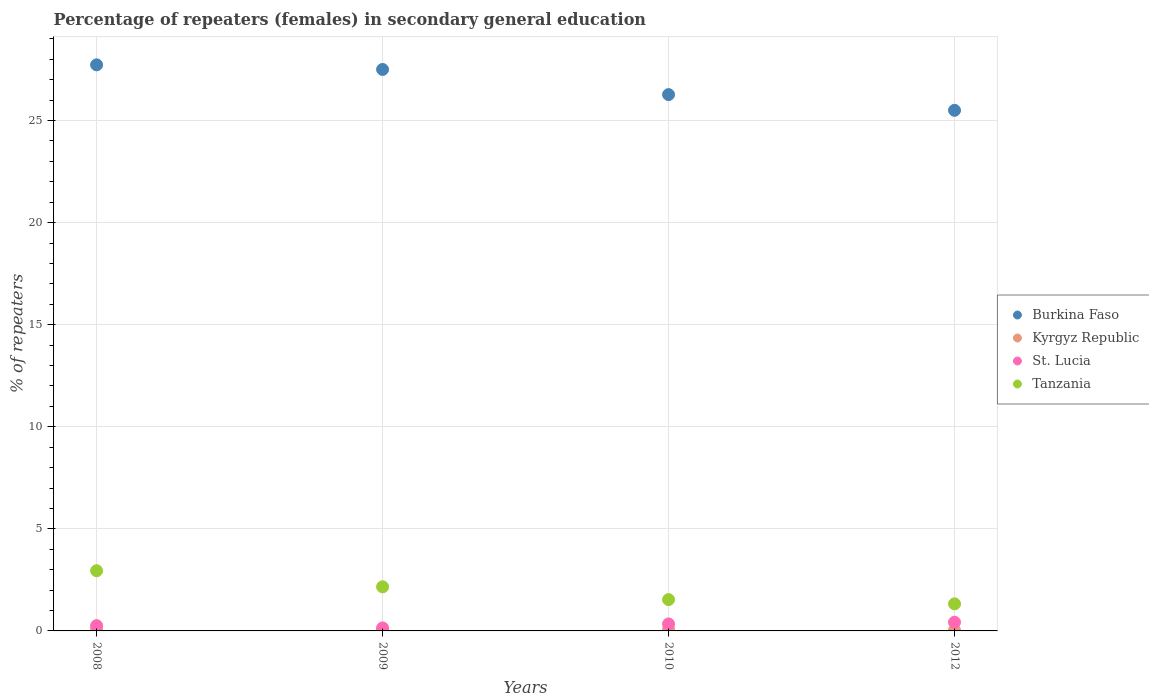Is the number of dotlines equal to the number of legend labels?
Offer a very short reply. Yes. What is the percentage of female repeaters in St. Lucia in 2012?
Provide a succinct answer. 0.43. Across all years, what is the maximum percentage of female repeaters in Tanzania?
Offer a very short reply. 2.95. Across all years, what is the minimum percentage of female repeaters in Burkina Faso?
Your answer should be very brief. 25.5. In which year was the percentage of female repeaters in Tanzania minimum?
Make the answer very short. 2012. What is the total percentage of female repeaters in Burkina Faso in the graph?
Your answer should be very brief. 107.01. What is the difference between the percentage of female repeaters in Tanzania in 2009 and that in 2010?
Ensure brevity in your answer.  0.63. What is the difference between the percentage of female repeaters in Kyrgyz Republic in 2010 and the percentage of female repeaters in Tanzania in 2012?
Offer a terse response. -1.25. What is the average percentage of female repeaters in Tanzania per year?
Make the answer very short. 1.99. In the year 2008, what is the difference between the percentage of female repeaters in Burkina Faso and percentage of female repeaters in Tanzania?
Provide a short and direct response. 24.78. In how many years, is the percentage of female repeaters in Kyrgyz Republic greater than 12 %?
Your answer should be very brief. 0. What is the ratio of the percentage of female repeaters in Kyrgyz Republic in 2009 to that in 2012?
Ensure brevity in your answer.  1.7. Is the difference between the percentage of female repeaters in Burkina Faso in 2009 and 2010 greater than the difference between the percentage of female repeaters in Tanzania in 2009 and 2010?
Your answer should be very brief. Yes. What is the difference between the highest and the second highest percentage of female repeaters in Kyrgyz Republic?
Make the answer very short. 0.01. What is the difference between the highest and the lowest percentage of female repeaters in Burkina Faso?
Keep it short and to the point. 2.23. In how many years, is the percentage of female repeaters in Tanzania greater than the average percentage of female repeaters in Tanzania taken over all years?
Your answer should be compact. 2. Is the sum of the percentage of female repeaters in Tanzania in 2009 and 2010 greater than the maximum percentage of female repeaters in Burkina Faso across all years?
Offer a very short reply. No. Is it the case that in every year, the sum of the percentage of female repeaters in Burkina Faso and percentage of female repeaters in Kyrgyz Republic  is greater than the percentage of female repeaters in St. Lucia?
Your response must be concise. Yes. Does the percentage of female repeaters in Burkina Faso monotonically increase over the years?
Make the answer very short. No. Is the percentage of female repeaters in Burkina Faso strictly less than the percentage of female repeaters in Kyrgyz Republic over the years?
Keep it short and to the point. No. How many years are there in the graph?
Offer a very short reply. 4. Does the graph contain any zero values?
Offer a very short reply. No. Does the graph contain grids?
Your answer should be compact. Yes. Where does the legend appear in the graph?
Give a very brief answer. Center right. What is the title of the graph?
Your answer should be compact. Percentage of repeaters (females) in secondary general education. What is the label or title of the Y-axis?
Your answer should be very brief. % of repeaters. What is the % of repeaters in Burkina Faso in 2008?
Your answer should be very brief. 27.73. What is the % of repeaters of Kyrgyz Republic in 2008?
Provide a short and direct response. 0.08. What is the % of repeaters in St. Lucia in 2008?
Offer a very short reply. 0.26. What is the % of repeaters in Tanzania in 2008?
Your answer should be compact. 2.95. What is the % of repeaters of Burkina Faso in 2009?
Ensure brevity in your answer.  27.5. What is the % of repeaters of Kyrgyz Republic in 2009?
Your answer should be very brief. 0.06. What is the % of repeaters in St. Lucia in 2009?
Your response must be concise. 0.15. What is the % of repeaters of Tanzania in 2009?
Give a very brief answer. 2.16. What is the % of repeaters in Burkina Faso in 2010?
Ensure brevity in your answer.  26.27. What is the % of repeaters in Kyrgyz Republic in 2010?
Make the answer very short. 0.08. What is the % of repeaters of St. Lucia in 2010?
Keep it short and to the point. 0.34. What is the % of repeaters in Tanzania in 2010?
Give a very brief answer. 1.53. What is the % of repeaters of Burkina Faso in 2012?
Offer a very short reply. 25.5. What is the % of repeaters of Kyrgyz Republic in 2012?
Keep it short and to the point. 0.03. What is the % of repeaters of St. Lucia in 2012?
Ensure brevity in your answer.  0.43. What is the % of repeaters in Tanzania in 2012?
Offer a very short reply. 1.33. Across all years, what is the maximum % of repeaters of Burkina Faso?
Provide a short and direct response. 27.73. Across all years, what is the maximum % of repeaters of Kyrgyz Republic?
Your answer should be very brief. 0.08. Across all years, what is the maximum % of repeaters in St. Lucia?
Provide a short and direct response. 0.43. Across all years, what is the maximum % of repeaters in Tanzania?
Provide a succinct answer. 2.95. Across all years, what is the minimum % of repeaters of Burkina Faso?
Provide a short and direct response. 25.5. Across all years, what is the minimum % of repeaters of Kyrgyz Republic?
Your answer should be very brief. 0.03. Across all years, what is the minimum % of repeaters in St. Lucia?
Your response must be concise. 0.15. Across all years, what is the minimum % of repeaters of Tanzania?
Your response must be concise. 1.33. What is the total % of repeaters of Burkina Faso in the graph?
Keep it short and to the point. 107.01. What is the total % of repeaters in Kyrgyz Republic in the graph?
Your response must be concise. 0.25. What is the total % of repeaters of St. Lucia in the graph?
Your answer should be very brief. 1.18. What is the total % of repeaters in Tanzania in the graph?
Offer a very short reply. 7.97. What is the difference between the % of repeaters in Burkina Faso in 2008 and that in 2009?
Your answer should be compact. 0.23. What is the difference between the % of repeaters in Kyrgyz Republic in 2008 and that in 2009?
Your response must be concise. 0.03. What is the difference between the % of repeaters of St. Lucia in 2008 and that in 2009?
Give a very brief answer. 0.11. What is the difference between the % of repeaters of Tanzania in 2008 and that in 2009?
Offer a very short reply. 0.79. What is the difference between the % of repeaters in Burkina Faso in 2008 and that in 2010?
Your answer should be very brief. 1.46. What is the difference between the % of repeaters of Kyrgyz Republic in 2008 and that in 2010?
Your response must be concise. 0.01. What is the difference between the % of repeaters of St. Lucia in 2008 and that in 2010?
Your answer should be compact. -0.08. What is the difference between the % of repeaters of Tanzania in 2008 and that in 2010?
Offer a terse response. 1.41. What is the difference between the % of repeaters of Burkina Faso in 2008 and that in 2012?
Give a very brief answer. 2.23. What is the difference between the % of repeaters of Kyrgyz Republic in 2008 and that in 2012?
Keep it short and to the point. 0.05. What is the difference between the % of repeaters of St. Lucia in 2008 and that in 2012?
Offer a very short reply. -0.17. What is the difference between the % of repeaters of Tanzania in 2008 and that in 2012?
Make the answer very short. 1.62. What is the difference between the % of repeaters in Burkina Faso in 2009 and that in 2010?
Offer a very short reply. 1.23. What is the difference between the % of repeaters of Kyrgyz Republic in 2009 and that in 2010?
Offer a terse response. -0.02. What is the difference between the % of repeaters in St. Lucia in 2009 and that in 2010?
Make the answer very short. -0.2. What is the difference between the % of repeaters of Tanzania in 2009 and that in 2010?
Keep it short and to the point. 0.63. What is the difference between the % of repeaters in Burkina Faso in 2009 and that in 2012?
Your response must be concise. 2. What is the difference between the % of repeaters in Kyrgyz Republic in 2009 and that in 2012?
Make the answer very short. 0.02. What is the difference between the % of repeaters in St. Lucia in 2009 and that in 2012?
Keep it short and to the point. -0.28. What is the difference between the % of repeaters in Tanzania in 2009 and that in 2012?
Your answer should be very brief. 0.84. What is the difference between the % of repeaters of Burkina Faso in 2010 and that in 2012?
Give a very brief answer. 0.77. What is the difference between the % of repeaters of Kyrgyz Republic in 2010 and that in 2012?
Ensure brevity in your answer.  0.04. What is the difference between the % of repeaters in St. Lucia in 2010 and that in 2012?
Ensure brevity in your answer.  -0.08. What is the difference between the % of repeaters in Tanzania in 2010 and that in 2012?
Your answer should be very brief. 0.21. What is the difference between the % of repeaters of Burkina Faso in 2008 and the % of repeaters of Kyrgyz Republic in 2009?
Ensure brevity in your answer.  27.67. What is the difference between the % of repeaters of Burkina Faso in 2008 and the % of repeaters of St. Lucia in 2009?
Your answer should be very brief. 27.58. What is the difference between the % of repeaters of Burkina Faso in 2008 and the % of repeaters of Tanzania in 2009?
Offer a very short reply. 25.57. What is the difference between the % of repeaters in Kyrgyz Republic in 2008 and the % of repeaters in St. Lucia in 2009?
Offer a very short reply. -0.06. What is the difference between the % of repeaters in Kyrgyz Republic in 2008 and the % of repeaters in Tanzania in 2009?
Offer a very short reply. -2.08. What is the difference between the % of repeaters of St. Lucia in 2008 and the % of repeaters of Tanzania in 2009?
Offer a very short reply. -1.9. What is the difference between the % of repeaters in Burkina Faso in 2008 and the % of repeaters in Kyrgyz Republic in 2010?
Provide a succinct answer. 27.65. What is the difference between the % of repeaters in Burkina Faso in 2008 and the % of repeaters in St. Lucia in 2010?
Provide a succinct answer. 27.39. What is the difference between the % of repeaters of Burkina Faso in 2008 and the % of repeaters of Tanzania in 2010?
Offer a terse response. 26.2. What is the difference between the % of repeaters of Kyrgyz Republic in 2008 and the % of repeaters of St. Lucia in 2010?
Your answer should be compact. -0.26. What is the difference between the % of repeaters in Kyrgyz Republic in 2008 and the % of repeaters in Tanzania in 2010?
Ensure brevity in your answer.  -1.45. What is the difference between the % of repeaters of St. Lucia in 2008 and the % of repeaters of Tanzania in 2010?
Provide a short and direct response. -1.27. What is the difference between the % of repeaters of Burkina Faso in 2008 and the % of repeaters of Kyrgyz Republic in 2012?
Your response must be concise. 27.7. What is the difference between the % of repeaters of Burkina Faso in 2008 and the % of repeaters of St. Lucia in 2012?
Your response must be concise. 27.3. What is the difference between the % of repeaters in Burkina Faso in 2008 and the % of repeaters in Tanzania in 2012?
Give a very brief answer. 26.41. What is the difference between the % of repeaters of Kyrgyz Republic in 2008 and the % of repeaters of St. Lucia in 2012?
Keep it short and to the point. -0.34. What is the difference between the % of repeaters of Kyrgyz Republic in 2008 and the % of repeaters of Tanzania in 2012?
Provide a short and direct response. -1.24. What is the difference between the % of repeaters in St. Lucia in 2008 and the % of repeaters in Tanzania in 2012?
Give a very brief answer. -1.06. What is the difference between the % of repeaters of Burkina Faso in 2009 and the % of repeaters of Kyrgyz Republic in 2010?
Ensure brevity in your answer.  27.43. What is the difference between the % of repeaters of Burkina Faso in 2009 and the % of repeaters of St. Lucia in 2010?
Keep it short and to the point. 27.16. What is the difference between the % of repeaters of Burkina Faso in 2009 and the % of repeaters of Tanzania in 2010?
Your answer should be compact. 25.97. What is the difference between the % of repeaters of Kyrgyz Republic in 2009 and the % of repeaters of St. Lucia in 2010?
Ensure brevity in your answer.  -0.29. What is the difference between the % of repeaters of Kyrgyz Republic in 2009 and the % of repeaters of Tanzania in 2010?
Offer a very short reply. -1.48. What is the difference between the % of repeaters in St. Lucia in 2009 and the % of repeaters in Tanzania in 2010?
Provide a succinct answer. -1.39. What is the difference between the % of repeaters in Burkina Faso in 2009 and the % of repeaters in Kyrgyz Republic in 2012?
Your answer should be very brief. 27.47. What is the difference between the % of repeaters in Burkina Faso in 2009 and the % of repeaters in St. Lucia in 2012?
Give a very brief answer. 27.08. What is the difference between the % of repeaters of Burkina Faso in 2009 and the % of repeaters of Tanzania in 2012?
Ensure brevity in your answer.  26.18. What is the difference between the % of repeaters of Kyrgyz Republic in 2009 and the % of repeaters of St. Lucia in 2012?
Your response must be concise. -0.37. What is the difference between the % of repeaters of Kyrgyz Republic in 2009 and the % of repeaters of Tanzania in 2012?
Provide a short and direct response. -1.27. What is the difference between the % of repeaters of St. Lucia in 2009 and the % of repeaters of Tanzania in 2012?
Your response must be concise. -1.18. What is the difference between the % of repeaters in Burkina Faso in 2010 and the % of repeaters in Kyrgyz Republic in 2012?
Give a very brief answer. 26.24. What is the difference between the % of repeaters of Burkina Faso in 2010 and the % of repeaters of St. Lucia in 2012?
Offer a terse response. 25.85. What is the difference between the % of repeaters of Burkina Faso in 2010 and the % of repeaters of Tanzania in 2012?
Offer a terse response. 24.95. What is the difference between the % of repeaters of Kyrgyz Republic in 2010 and the % of repeaters of St. Lucia in 2012?
Your answer should be very brief. -0.35. What is the difference between the % of repeaters in Kyrgyz Republic in 2010 and the % of repeaters in Tanzania in 2012?
Make the answer very short. -1.25. What is the difference between the % of repeaters of St. Lucia in 2010 and the % of repeaters of Tanzania in 2012?
Offer a very short reply. -0.98. What is the average % of repeaters of Burkina Faso per year?
Keep it short and to the point. 26.75. What is the average % of repeaters in Kyrgyz Republic per year?
Offer a very short reply. 0.06. What is the average % of repeaters of St. Lucia per year?
Give a very brief answer. 0.29. What is the average % of repeaters in Tanzania per year?
Your answer should be very brief. 1.99. In the year 2008, what is the difference between the % of repeaters of Burkina Faso and % of repeaters of Kyrgyz Republic?
Make the answer very short. 27.65. In the year 2008, what is the difference between the % of repeaters of Burkina Faso and % of repeaters of St. Lucia?
Provide a succinct answer. 27.47. In the year 2008, what is the difference between the % of repeaters in Burkina Faso and % of repeaters in Tanzania?
Keep it short and to the point. 24.78. In the year 2008, what is the difference between the % of repeaters in Kyrgyz Republic and % of repeaters in St. Lucia?
Make the answer very short. -0.18. In the year 2008, what is the difference between the % of repeaters of Kyrgyz Republic and % of repeaters of Tanzania?
Make the answer very short. -2.86. In the year 2008, what is the difference between the % of repeaters of St. Lucia and % of repeaters of Tanzania?
Offer a terse response. -2.69. In the year 2009, what is the difference between the % of repeaters of Burkina Faso and % of repeaters of Kyrgyz Republic?
Keep it short and to the point. 27.45. In the year 2009, what is the difference between the % of repeaters of Burkina Faso and % of repeaters of St. Lucia?
Your response must be concise. 27.36. In the year 2009, what is the difference between the % of repeaters in Burkina Faso and % of repeaters in Tanzania?
Keep it short and to the point. 25.34. In the year 2009, what is the difference between the % of repeaters of Kyrgyz Republic and % of repeaters of St. Lucia?
Offer a very short reply. -0.09. In the year 2009, what is the difference between the % of repeaters of Kyrgyz Republic and % of repeaters of Tanzania?
Ensure brevity in your answer.  -2.1. In the year 2009, what is the difference between the % of repeaters of St. Lucia and % of repeaters of Tanzania?
Your answer should be compact. -2.01. In the year 2010, what is the difference between the % of repeaters of Burkina Faso and % of repeaters of Kyrgyz Republic?
Ensure brevity in your answer.  26.2. In the year 2010, what is the difference between the % of repeaters of Burkina Faso and % of repeaters of St. Lucia?
Make the answer very short. 25.93. In the year 2010, what is the difference between the % of repeaters in Burkina Faso and % of repeaters in Tanzania?
Your response must be concise. 24.74. In the year 2010, what is the difference between the % of repeaters of Kyrgyz Republic and % of repeaters of St. Lucia?
Your response must be concise. -0.26. In the year 2010, what is the difference between the % of repeaters of Kyrgyz Republic and % of repeaters of Tanzania?
Your answer should be very brief. -1.46. In the year 2010, what is the difference between the % of repeaters in St. Lucia and % of repeaters in Tanzania?
Make the answer very short. -1.19. In the year 2012, what is the difference between the % of repeaters of Burkina Faso and % of repeaters of Kyrgyz Republic?
Your answer should be very brief. 25.47. In the year 2012, what is the difference between the % of repeaters of Burkina Faso and % of repeaters of St. Lucia?
Give a very brief answer. 25.08. In the year 2012, what is the difference between the % of repeaters in Burkina Faso and % of repeaters in Tanzania?
Make the answer very short. 24.18. In the year 2012, what is the difference between the % of repeaters in Kyrgyz Republic and % of repeaters in St. Lucia?
Make the answer very short. -0.39. In the year 2012, what is the difference between the % of repeaters in Kyrgyz Republic and % of repeaters in Tanzania?
Provide a succinct answer. -1.29. In the year 2012, what is the difference between the % of repeaters in St. Lucia and % of repeaters in Tanzania?
Ensure brevity in your answer.  -0.9. What is the ratio of the % of repeaters in Burkina Faso in 2008 to that in 2009?
Your answer should be very brief. 1.01. What is the ratio of the % of repeaters in Kyrgyz Republic in 2008 to that in 2009?
Make the answer very short. 1.51. What is the ratio of the % of repeaters of St. Lucia in 2008 to that in 2009?
Make the answer very short. 1.77. What is the ratio of the % of repeaters of Tanzania in 2008 to that in 2009?
Your answer should be very brief. 1.36. What is the ratio of the % of repeaters in Burkina Faso in 2008 to that in 2010?
Offer a very short reply. 1.06. What is the ratio of the % of repeaters of Kyrgyz Republic in 2008 to that in 2010?
Provide a short and direct response. 1.09. What is the ratio of the % of repeaters of St. Lucia in 2008 to that in 2010?
Keep it short and to the point. 0.76. What is the ratio of the % of repeaters in Tanzania in 2008 to that in 2010?
Provide a short and direct response. 1.92. What is the ratio of the % of repeaters in Burkina Faso in 2008 to that in 2012?
Provide a succinct answer. 1.09. What is the ratio of the % of repeaters in Kyrgyz Republic in 2008 to that in 2012?
Offer a very short reply. 2.57. What is the ratio of the % of repeaters of St. Lucia in 2008 to that in 2012?
Provide a succinct answer. 0.61. What is the ratio of the % of repeaters of Tanzania in 2008 to that in 2012?
Provide a succinct answer. 2.23. What is the ratio of the % of repeaters of Burkina Faso in 2009 to that in 2010?
Your answer should be compact. 1.05. What is the ratio of the % of repeaters in Kyrgyz Republic in 2009 to that in 2010?
Provide a succinct answer. 0.72. What is the ratio of the % of repeaters of St. Lucia in 2009 to that in 2010?
Provide a succinct answer. 0.43. What is the ratio of the % of repeaters in Tanzania in 2009 to that in 2010?
Provide a short and direct response. 1.41. What is the ratio of the % of repeaters in Burkina Faso in 2009 to that in 2012?
Ensure brevity in your answer.  1.08. What is the ratio of the % of repeaters in Kyrgyz Republic in 2009 to that in 2012?
Your response must be concise. 1.7. What is the ratio of the % of repeaters in St. Lucia in 2009 to that in 2012?
Offer a very short reply. 0.35. What is the ratio of the % of repeaters in Tanzania in 2009 to that in 2012?
Ensure brevity in your answer.  1.63. What is the ratio of the % of repeaters in Burkina Faso in 2010 to that in 2012?
Your response must be concise. 1.03. What is the ratio of the % of repeaters of Kyrgyz Republic in 2010 to that in 2012?
Make the answer very short. 2.36. What is the ratio of the % of repeaters of St. Lucia in 2010 to that in 2012?
Make the answer very short. 0.8. What is the ratio of the % of repeaters of Tanzania in 2010 to that in 2012?
Your answer should be compact. 1.16. What is the difference between the highest and the second highest % of repeaters of Burkina Faso?
Provide a short and direct response. 0.23. What is the difference between the highest and the second highest % of repeaters of Kyrgyz Republic?
Make the answer very short. 0.01. What is the difference between the highest and the second highest % of repeaters of St. Lucia?
Ensure brevity in your answer.  0.08. What is the difference between the highest and the second highest % of repeaters in Tanzania?
Your answer should be very brief. 0.79. What is the difference between the highest and the lowest % of repeaters of Burkina Faso?
Your response must be concise. 2.23. What is the difference between the highest and the lowest % of repeaters of Kyrgyz Republic?
Provide a succinct answer. 0.05. What is the difference between the highest and the lowest % of repeaters in St. Lucia?
Provide a short and direct response. 0.28. What is the difference between the highest and the lowest % of repeaters in Tanzania?
Ensure brevity in your answer.  1.62. 